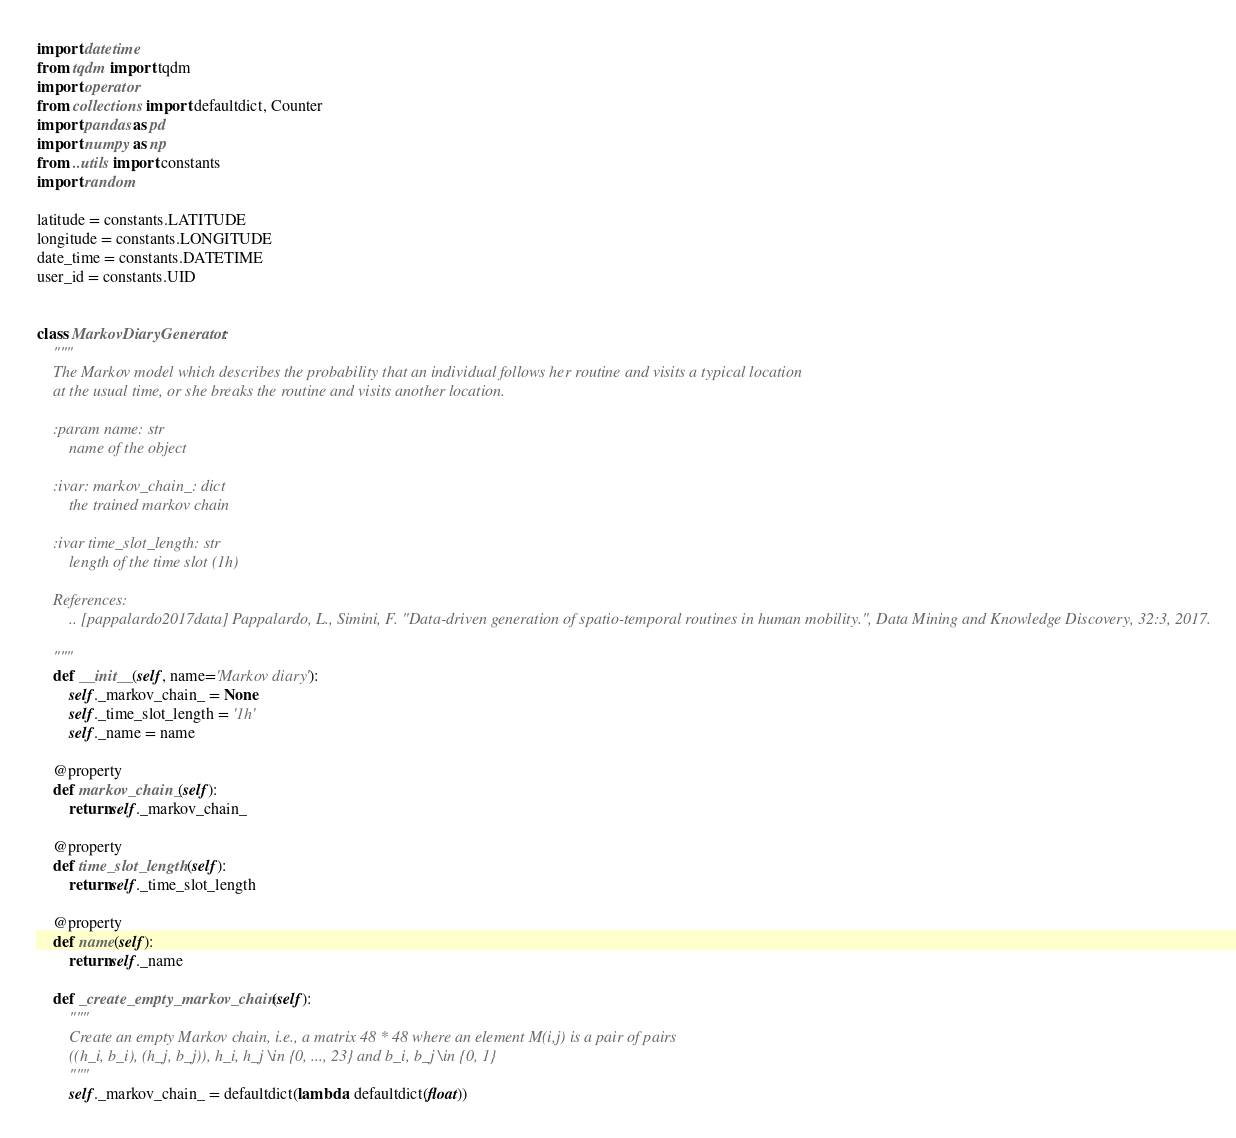Convert code to text. <code><loc_0><loc_0><loc_500><loc_500><_Python_>import datetime
from tqdm import tqdm
import operator
from collections import defaultdict, Counter
import pandas as pd
import numpy as np
from ..utils import constants
import random

latitude = constants.LATITUDE
longitude = constants.LONGITUDE
date_time = constants.DATETIME
user_id = constants.UID


class MarkovDiaryGenerator:
    """
    The Markov model which describes the probability that an individual follows her routine and visits a typical location
    at the usual time, or she breaks the routine and visits another location.

    :param name: str
        name of the object

    :ivar: markov_chain_: dict
        the trained markov chain

    :ivar time_slot_length: str
        length of the time slot (1h)

    References:
        .. [pappalardo2017data] Pappalardo, L., Simini, F. "Data-driven generation of spatio-temporal routines in human mobility.", Data Mining and Knowledge Discovery, 32:3, 2017.

    """
    def __init__(self, name='Markov diary'):
        self._markov_chain_ = None
        self._time_slot_length = '1h'
        self._name = name

    @property
    def markov_chain_(self):
        return self._markov_chain_

    @property
    def time_slot_length(self):
        return self._time_slot_length

    @property
    def name(self):
        return self._name

    def _create_empty_markov_chain(self):
        """
        Create an empty Markov chain, i.e., a matrix 48 * 48 where an element M(i,j) is a pair of pairs
        ((h_i, b_i), (h_j, b_j)), h_i, h_j \in {0, ..., 23} and b_i, b_j \in {0, 1}
        """
        self._markov_chain_ = defaultdict(lambda: defaultdict(float))</code> 